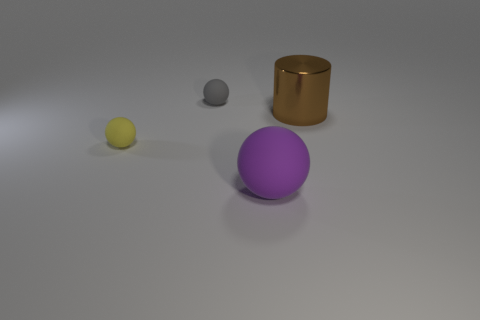What is the sphere that is both on the right side of the yellow sphere and behind the large purple matte ball made of?
Make the answer very short. Rubber. What number of purple spheres are the same size as the brown shiny thing?
Provide a short and direct response. 1. The ball behind the large object to the right of the big purple rubber thing is what color?
Offer a terse response. Gray. Are there any big brown shiny things?
Your answer should be compact. Yes. Is the shape of the purple thing the same as the tiny gray rubber object?
Provide a short and direct response. Yes. How many brown metallic cylinders are behind the gray matte thing that is left of the big cylinder?
Provide a short and direct response. 0. How many balls are both in front of the gray ball and behind the big purple matte thing?
Give a very brief answer. 1. How many things are green metallic cubes or small rubber balls in front of the shiny cylinder?
Give a very brief answer. 1. The purple thing that is the same material as the small gray thing is what size?
Provide a succinct answer. Large. What is the shape of the rubber object that is right of the small object that is to the right of the small yellow thing?
Your answer should be compact. Sphere. 